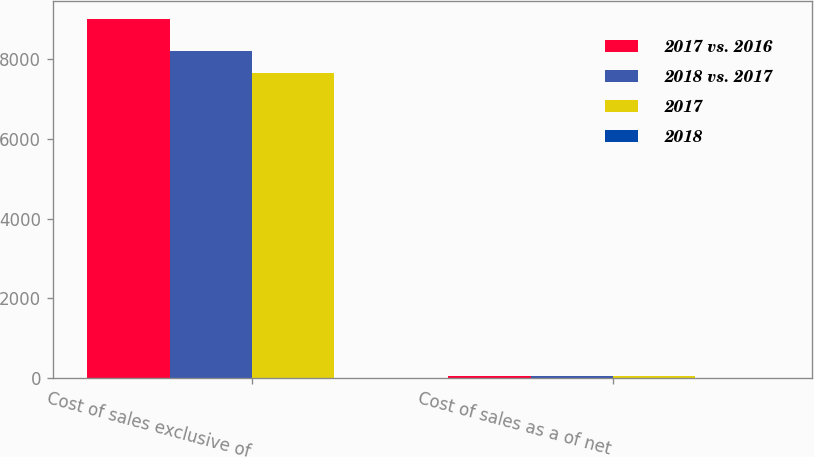Convert chart to OTSL. <chart><loc_0><loc_0><loc_500><loc_500><stacked_bar_chart><ecel><fcel>Cost of sales exclusive of<fcel>Cost of sales as a of net<nl><fcel>2017 vs. 2016<fcel>9001<fcel>58.5<nl><fcel>2018 vs. 2017<fcel>8209<fcel>55.7<nl><fcel>2017<fcel>7665<fcel>53.7<nl><fcel>2018<fcel>9.6<fcel>2.8<nl></chart> 